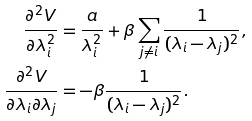Convert formula to latex. <formula><loc_0><loc_0><loc_500><loc_500>\frac { \partial ^ { 2 } V } { \partial \lambda _ { i } ^ { 2 } } & = \frac { a } { \lambda _ { i } ^ { 2 } } + \beta \sum _ { j \ne i } \frac { 1 } { ( \lambda _ { i } - \lambda _ { j } ) ^ { 2 } } , \\ \frac { \partial ^ { 2 } V } { \partial \lambda _ { i } \partial \lambda _ { j } } & = - \beta \frac { 1 } { ( \lambda _ { i } - \lambda _ { j } ) ^ { 2 } } .</formula> 